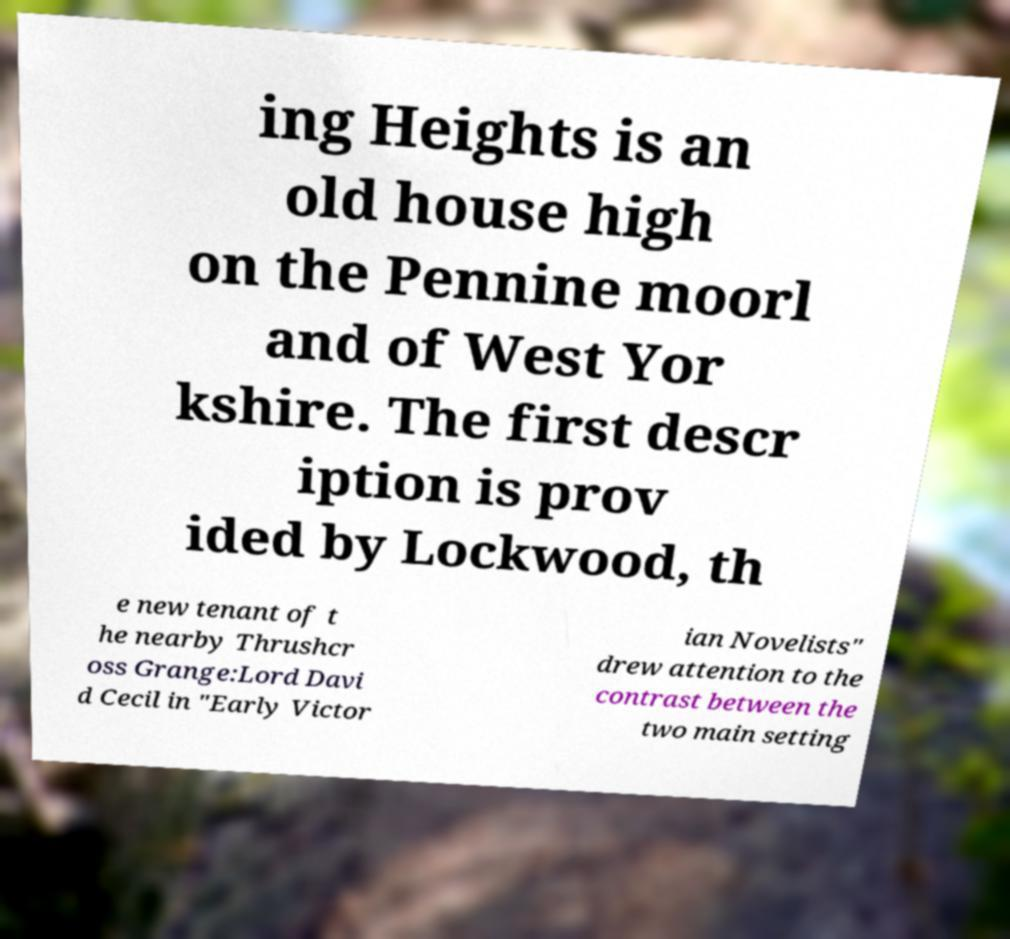Could you extract and type out the text from this image? ing Heights is an old house high on the Pennine moorl and of West Yor kshire. The first descr iption is prov ided by Lockwood, th e new tenant of t he nearby Thrushcr oss Grange:Lord Davi d Cecil in "Early Victor ian Novelists" drew attention to the contrast between the two main setting 